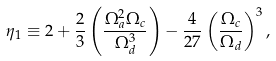<formula> <loc_0><loc_0><loc_500><loc_500>\eta _ { 1 } \equiv 2 + \frac { 2 } { 3 } \left ( \frac { \Omega _ { a } ^ { 2 } \Omega _ { c } } { \Omega _ { d } ^ { 3 } } \right ) - \frac { 4 } { 2 7 } \left ( \frac { \Omega _ { c } } { \Omega _ { d } } \right ) ^ { 3 } ,</formula> 